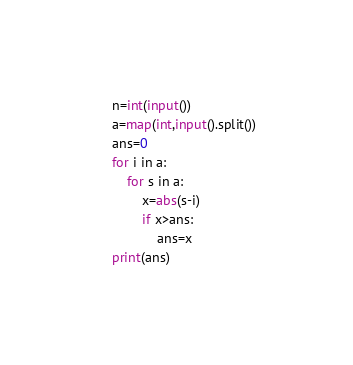Convert code to text. <code><loc_0><loc_0><loc_500><loc_500><_Python_>n=int(input())
a=map(int,input().split())
ans=0
for i in a:
    for s in a:
        x=abs(s-i)
        if x>ans:
            ans=x
print(ans)
</code> 